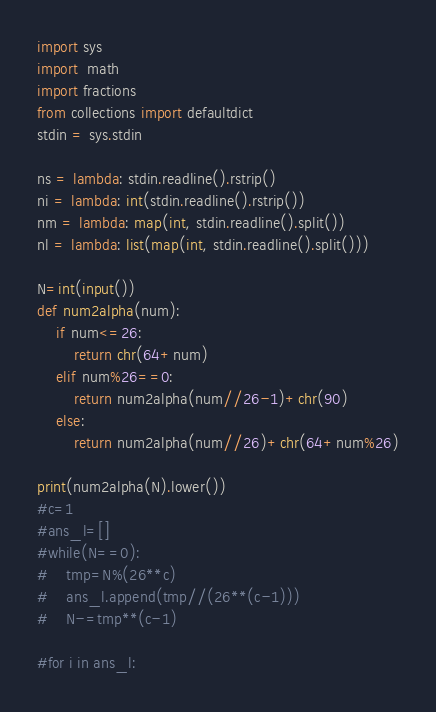Convert code to text. <code><loc_0><loc_0><loc_500><loc_500><_Python_>import sys
import  math
import fractions
from collections import defaultdict
stdin = sys.stdin
     
ns = lambda: stdin.readline().rstrip()
ni = lambda: int(stdin.readline().rstrip())
nm = lambda: map(int, stdin.readline().split())
nl = lambda: list(map(int, stdin.readline().split()))

N=int(input())
def num2alpha(num):
    if num<=26:
        return chr(64+num)
    elif num%26==0:
        return num2alpha(num//26-1)+chr(90)
    else:
        return num2alpha(num//26)+chr(64+num%26)

print(num2alpha(N).lower())
#c=1
#ans_l=[]
#while(N==0):
#    tmp=N%(26**c)
#    ans_l.append(tmp//(26**(c-1)))
#    N-=tmp**(c-1)

#for i in ans_l:


</code> 